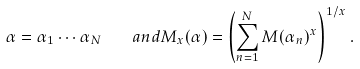<formula> <loc_0><loc_0><loc_500><loc_500>\alpha = \alpha _ { 1 } \cdots \alpha _ { N } \quad a n d M _ { x } ( \alpha ) = \left ( \sum _ { n = 1 } ^ { N } M ( \alpha _ { n } ) ^ { x } \right ) ^ { 1 / x } .</formula> 